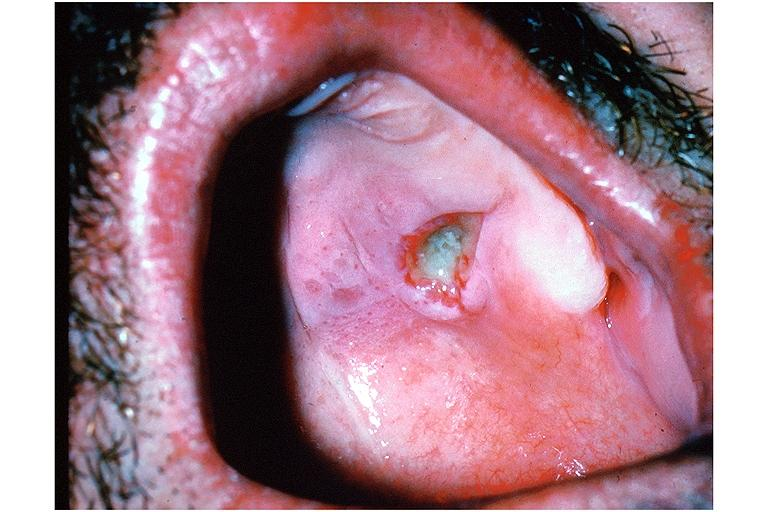does hemorrhagic corpus luteum show necrotizing sialometaplasia?
Answer the question using a single word or phrase. No 